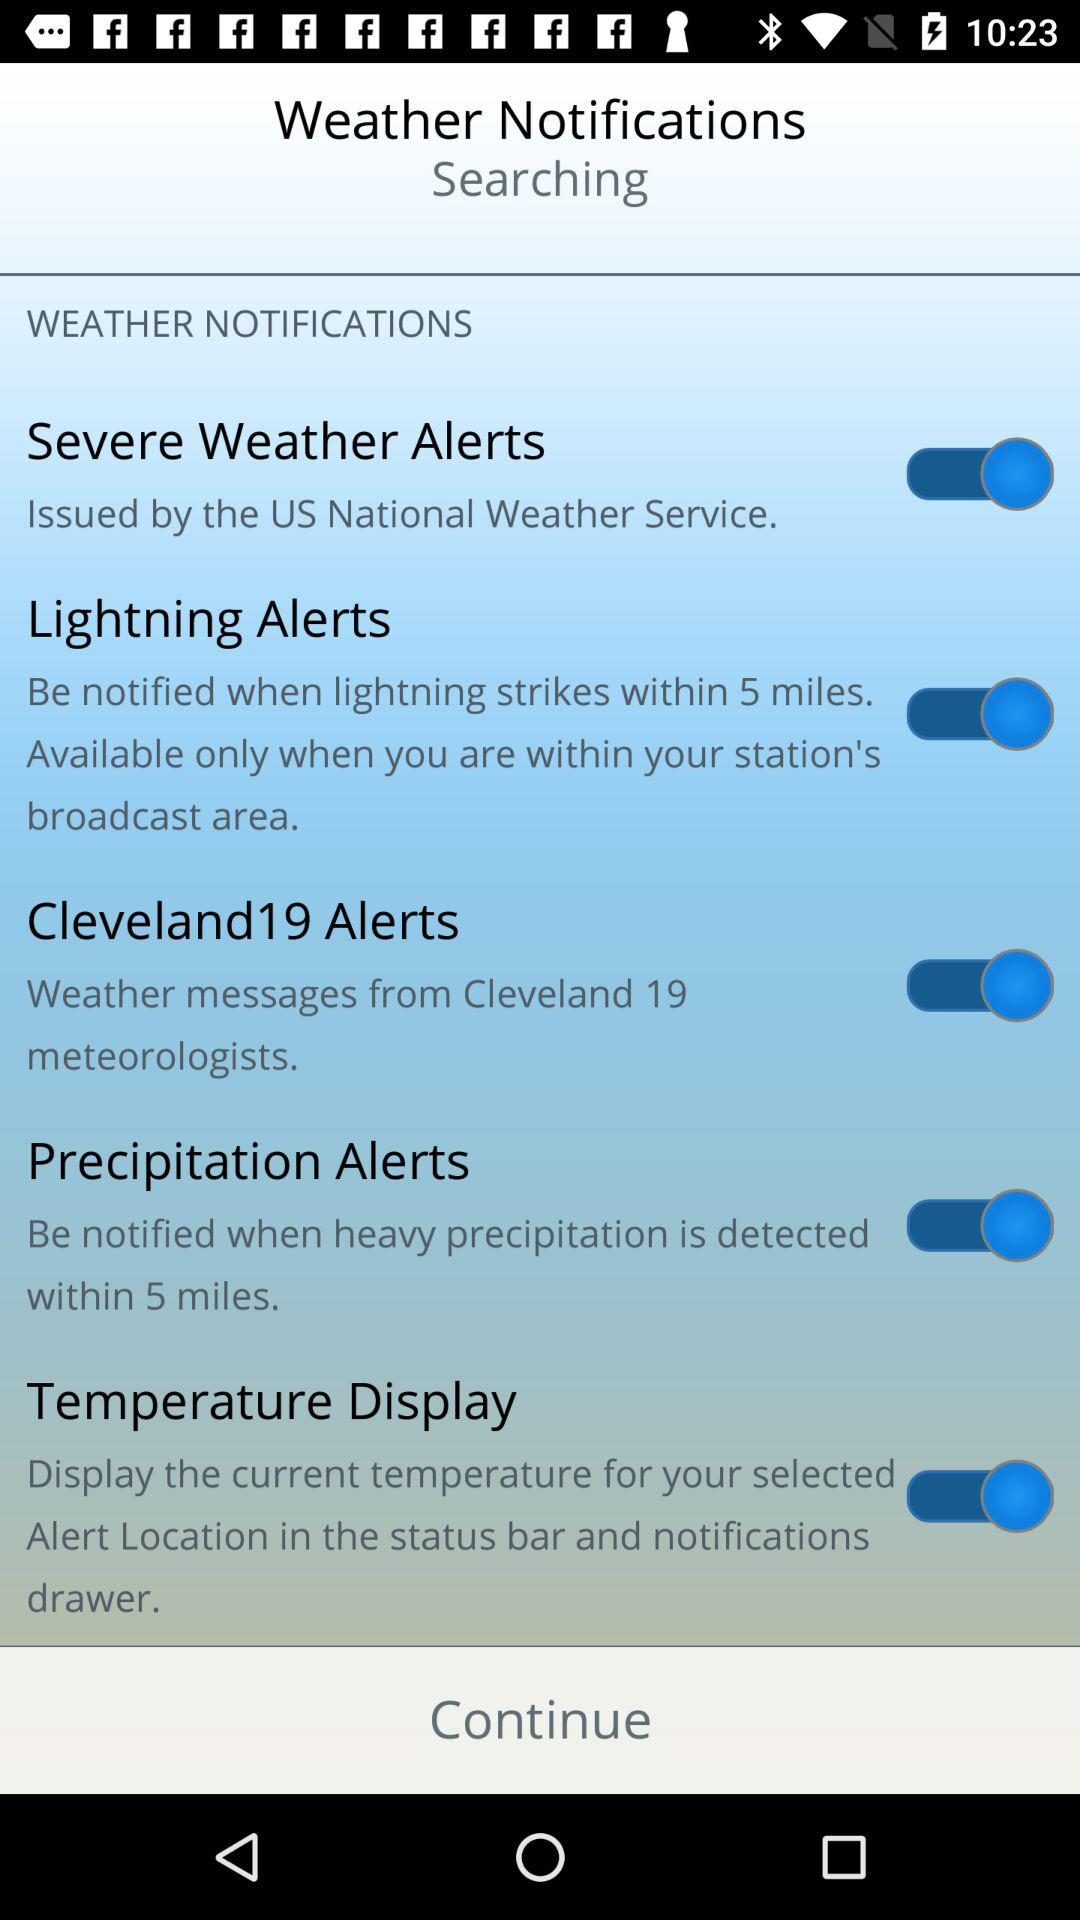Are there any alerts that are specifically available based on regional criteria? Yes, the 'Lightning Alerts' and 'Cleveland19 Alerts' are based on regional criteria. 'Lightning Alerts' are activated only when you are within 5 miles of a detected lightning strike and within your station's broadcast area, while 'Cleveland19 Alerts' deliver weather messages from Cleveland 19 meteorologists, presumably focusing on the Cleveland area. 